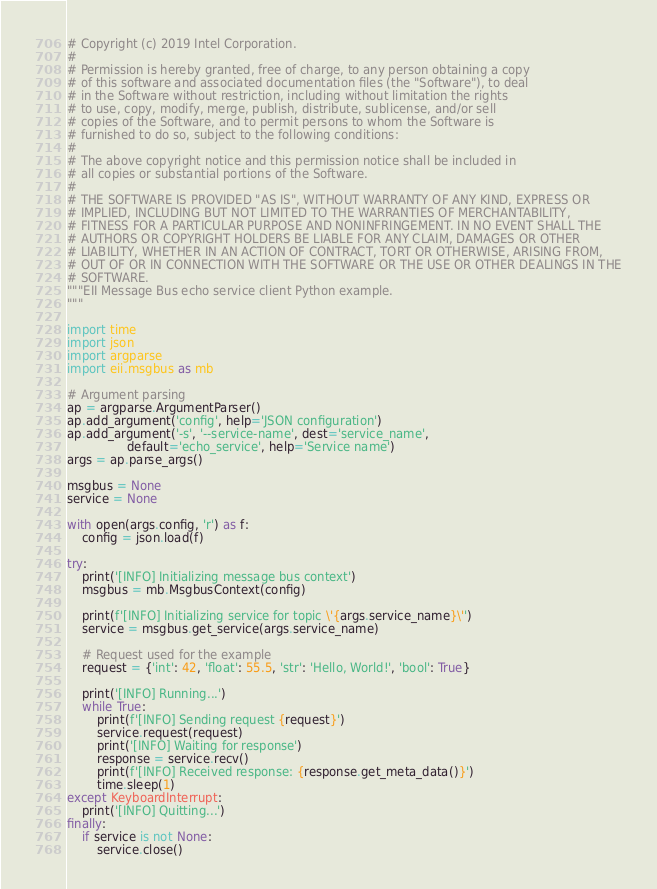<code> <loc_0><loc_0><loc_500><loc_500><_Python_># Copyright (c) 2019 Intel Corporation.
#
# Permission is hereby granted, free of charge, to any person obtaining a copy
# of this software and associated documentation files (the "Software"), to deal
# in the Software without restriction, including without limitation the rights
# to use, copy, modify, merge, publish, distribute, sublicense, and/or sell
# copies of the Software, and to permit persons to whom the Software is
# furnished to do so, subject to the following conditions:
#
# The above copyright notice and this permission notice shall be included in
# all copies or substantial portions of the Software.
#
# THE SOFTWARE IS PROVIDED "AS IS", WITHOUT WARRANTY OF ANY KIND, EXPRESS OR
# IMPLIED, INCLUDING BUT NOT LIMITED TO THE WARRANTIES OF MERCHANTABILITY,
# FITNESS FOR A PARTICULAR PURPOSE AND NONINFRINGEMENT. IN NO EVENT SHALL THE
# AUTHORS OR COPYRIGHT HOLDERS BE LIABLE FOR ANY CLAIM, DAMAGES OR OTHER
# LIABILITY, WHETHER IN AN ACTION OF CONTRACT, TORT OR OTHERWISE, ARISING FROM,
# OUT OF OR IN CONNECTION WITH THE SOFTWARE OR THE USE OR OTHER DEALINGS IN THE
# SOFTWARE.
"""EII Message Bus echo service client Python example.
"""

import time
import json
import argparse
import eii.msgbus as mb

# Argument parsing
ap = argparse.ArgumentParser()
ap.add_argument('config', help='JSON configuration')
ap.add_argument('-s', '--service-name', dest='service_name',
                default='echo_service', help='Service name')
args = ap.parse_args()

msgbus = None
service = None

with open(args.config, 'r') as f:
    config = json.load(f)

try:
    print('[INFO] Initializing message bus context')
    msgbus = mb.MsgbusContext(config)

    print(f'[INFO] Initializing service for topic \'{args.service_name}\'')
    service = msgbus.get_service(args.service_name)

    # Request used for the example
    request = {'int': 42, 'float': 55.5, 'str': 'Hello, World!', 'bool': True}

    print('[INFO] Running...')
    while True:
        print(f'[INFO] Sending request {request}')
        service.request(request)
        print('[INFO] Waiting for response')
        response = service.recv()
        print(f'[INFO] Received response: {response.get_meta_data()}')
        time.sleep(1)
except KeyboardInterrupt:
    print('[INFO] Quitting...')
finally:
    if service is not None:
        service.close()
</code> 